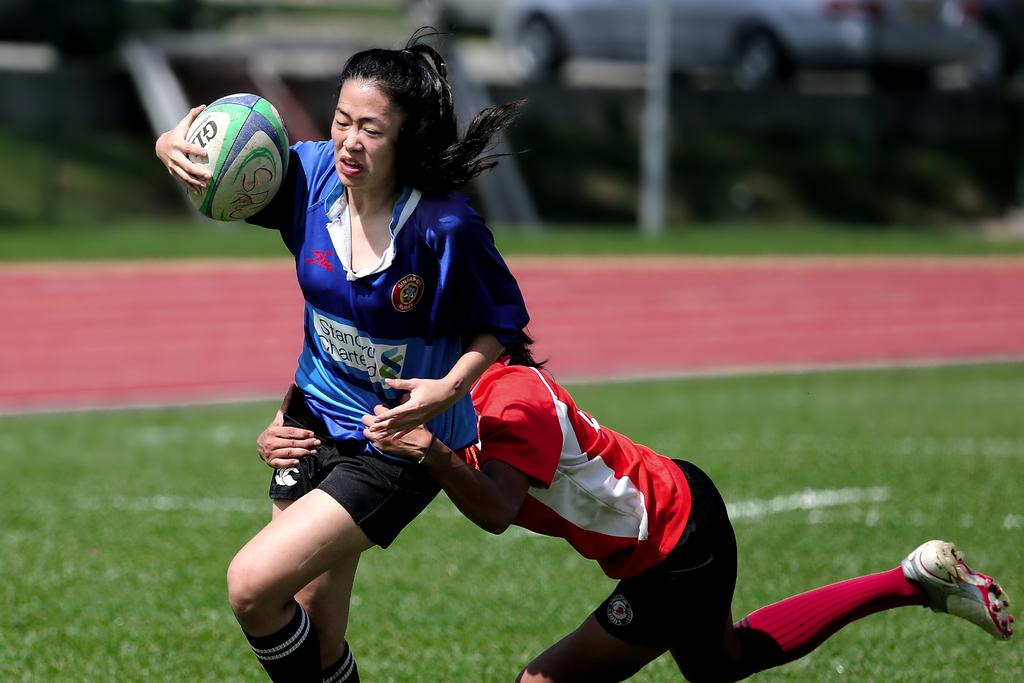How many people are in the image? There are two women in the image. What is one of the women holding in her hand? One of the women is holding a ball in her hand. What can be seen in the background of the image? There is a car and grass in the background of the image. How would you describe the appearance of the background? The background of the image is blurred. What type of scarf is the woman wearing on the page in the image? There is no woman wearing a scarf on a page in the image; the image features two women and a blurred background. 